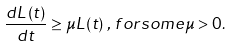Convert formula to latex. <formula><loc_0><loc_0><loc_500><loc_500>\frac { d L \left ( t \right ) } { d t } \geq \mu L \left ( t \right ) \, , \, f o r s o m e \mu > 0 .</formula> 